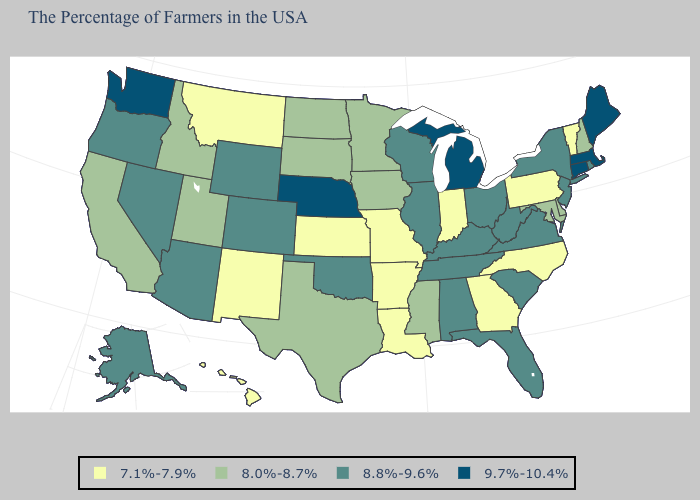Name the states that have a value in the range 8.0%-8.7%?
Give a very brief answer. New Hampshire, Delaware, Maryland, Mississippi, Minnesota, Iowa, Texas, South Dakota, North Dakota, Utah, Idaho, California. Does Michigan have the highest value in the MidWest?
Keep it brief. Yes. Does the first symbol in the legend represent the smallest category?
Be succinct. Yes. Does New Hampshire have a lower value than New Mexico?
Concise answer only. No. Which states have the highest value in the USA?
Write a very short answer. Maine, Massachusetts, Connecticut, Michigan, Nebraska, Washington. Name the states that have a value in the range 9.7%-10.4%?
Answer briefly. Maine, Massachusetts, Connecticut, Michigan, Nebraska, Washington. What is the value of Kentucky?
Keep it brief. 8.8%-9.6%. Does Ohio have the same value as Pennsylvania?
Concise answer only. No. What is the value of Ohio?
Give a very brief answer. 8.8%-9.6%. Among the states that border Idaho , which have the lowest value?
Write a very short answer. Montana. What is the value of New York?
Quick response, please. 8.8%-9.6%. Does West Virginia have a higher value than Idaho?
Quick response, please. Yes. Name the states that have a value in the range 7.1%-7.9%?
Quick response, please. Vermont, Pennsylvania, North Carolina, Georgia, Indiana, Louisiana, Missouri, Arkansas, Kansas, New Mexico, Montana, Hawaii. What is the value of Kansas?
Quick response, please. 7.1%-7.9%. Does the map have missing data?
Concise answer only. No. 